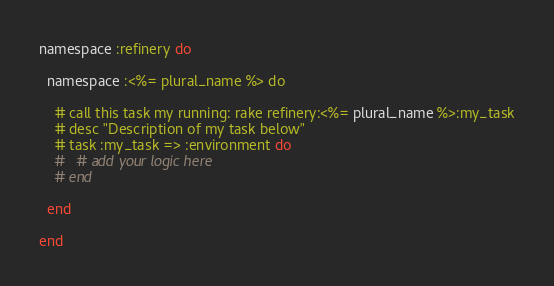<code> <loc_0><loc_0><loc_500><loc_500><_Ruby_>namespace :refinery do
  
  namespace :<%= plural_name %> do
    
    # call this task my running: rake refinery:<%= plural_name %>:my_task
    # desc "Description of my task below"
    # task :my_task => :environment do
    #   # add your logic here
    # end
  
  end
  
end</code> 